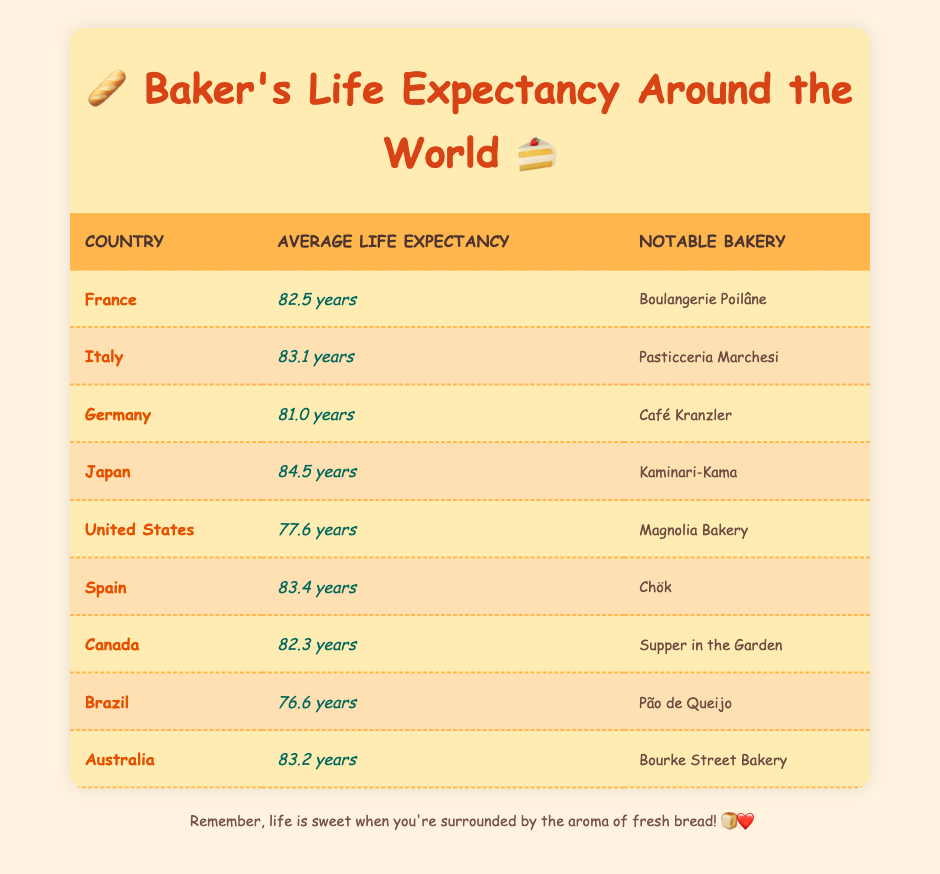What is the life expectancy of bakers in Japan? The table lists Japan with an average life expectancy of 84.5 years. You can find this information directly under the "Average Life Expectancy" column for the corresponding row of Japan.
Answer: 84.5 years Which country has the lowest life expectancy for bakers? In the table, Brazil has the lowest life expectancy at 76.6 years, which is listed in the appropriate column.
Answer: Brazil at 76.6 years What is the difference in life expectancy between bakers in Italy and Germany? To find this difference, subtract the life expectancy of Germany (81.0 years) from that of Italy (83.1 years): 83.1 - 81.0 = 2.1 years.
Answer: 2.1 years Are bakers in Spain expected to live longer than those in the United States? Spain has an average life expectancy of 83.4 years while the United States has 77.6 years. Since 83.4 is greater than 77.6, the statement is true.
Answer: Yes What is the average life expectancy for bakers in Canada and Australia combined? To find the average, sum the life expectancies: Canada (82.3 years) + Australia (83.2 years) = 165.5 years, then divide by 2: 165.5 / 2 = 82.75 years.
Answer: 82.75 years How many countries listed have a life expectancy above 82 years? By assessing each country's life expectancy in the table, you can count France (82.5), Italy (83.1), Japan (84.5), Spain (83.4), Australia (83.2), and Canada (82.3). This sums up to 6 countries.
Answer: 6 countries What notable bakery corresponds with the life expectancy of Germany? The table states that the notable bakery in Germany is "Café Kranzler," which is listed in the third column next to Germany's life expectancy.
Answer: Café Kranzler What percentage of the countries listed have an average life expectancy of over 80 years? There are 9 countries in total, and counting those above 80 years gives: France (82.5), Italy (83.1), Germany (81.0), Japan (84.5), Spain (83.4), and Canada (82.3) which totals 6. Compute the percentage: (6/9) * 100 = 66.67%.
Answer: 66.67% 